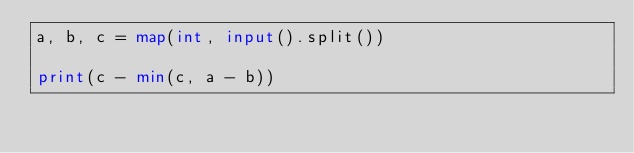<code> <loc_0><loc_0><loc_500><loc_500><_Python_>a, b, c = map(int, input().split())

print(c - min(c, a - b))
</code> 